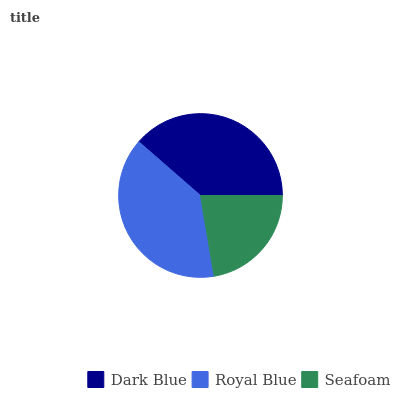Is Seafoam the minimum?
Answer yes or no. Yes. Is Royal Blue the maximum?
Answer yes or no. Yes. Is Royal Blue the minimum?
Answer yes or no. No. Is Seafoam the maximum?
Answer yes or no. No. Is Royal Blue greater than Seafoam?
Answer yes or no. Yes. Is Seafoam less than Royal Blue?
Answer yes or no. Yes. Is Seafoam greater than Royal Blue?
Answer yes or no. No. Is Royal Blue less than Seafoam?
Answer yes or no. No. Is Dark Blue the high median?
Answer yes or no. Yes. Is Dark Blue the low median?
Answer yes or no. Yes. Is Seafoam the high median?
Answer yes or no. No. Is Seafoam the low median?
Answer yes or no. No. 